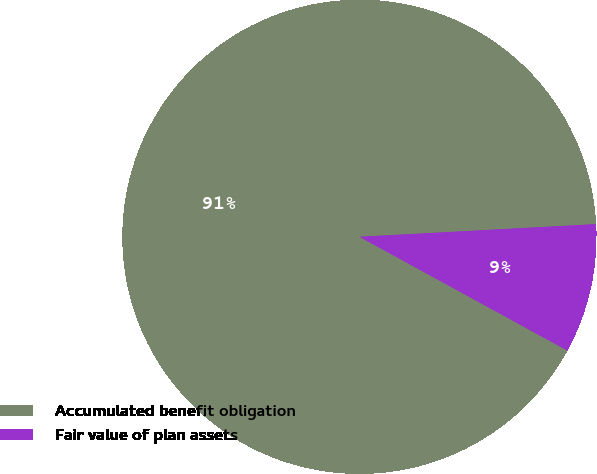Convert chart. <chart><loc_0><loc_0><loc_500><loc_500><pie_chart><fcel>Accumulated benefit obligation<fcel>Fair value of plan assets<nl><fcel>91.18%<fcel>8.82%<nl></chart> 